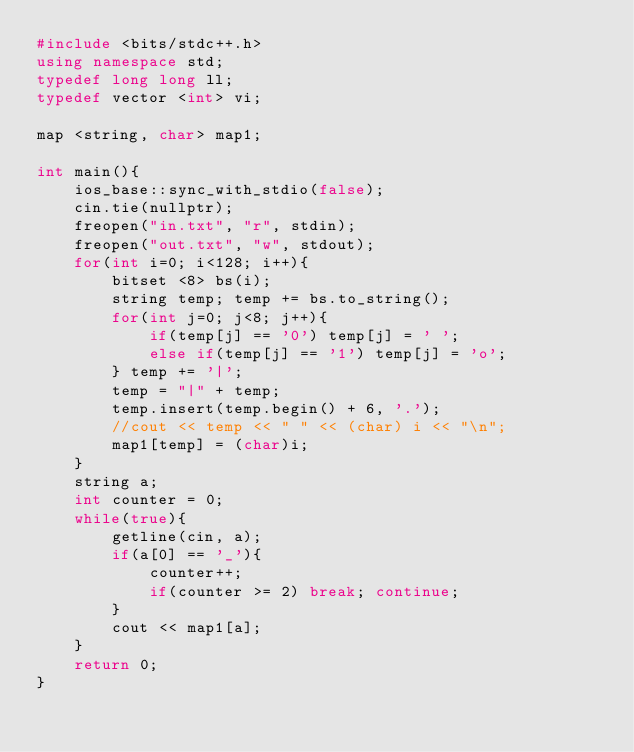Convert code to text. <code><loc_0><loc_0><loc_500><loc_500><_C++_>#include <bits/stdc++.h>
using namespace std;
typedef long long ll;
typedef vector <int> vi;

map <string, char> map1;

int main(){
    ios_base::sync_with_stdio(false);
    cin.tie(nullptr);
    freopen("in.txt", "r", stdin);
    freopen("out.txt", "w", stdout);
    for(int i=0; i<128; i++){
        bitset <8> bs(i);
        string temp; temp += bs.to_string();
        for(int j=0; j<8; j++){
            if(temp[j] == '0') temp[j] = ' ';
            else if(temp[j] == '1') temp[j] = 'o';
        } temp += '|';
        temp = "|" + temp;
        temp.insert(temp.begin() + 6, '.');
        //cout << temp << " " << (char) i << "\n";
        map1[temp] = (char)i;
    }
    string a;
    int counter = 0;
    while(true){
        getline(cin, a);
        if(a[0] == '_'){
            counter++;
            if(counter >= 2) break; continue;
        }
        cout << map1[a];
    }
    return 0;
}</code> 